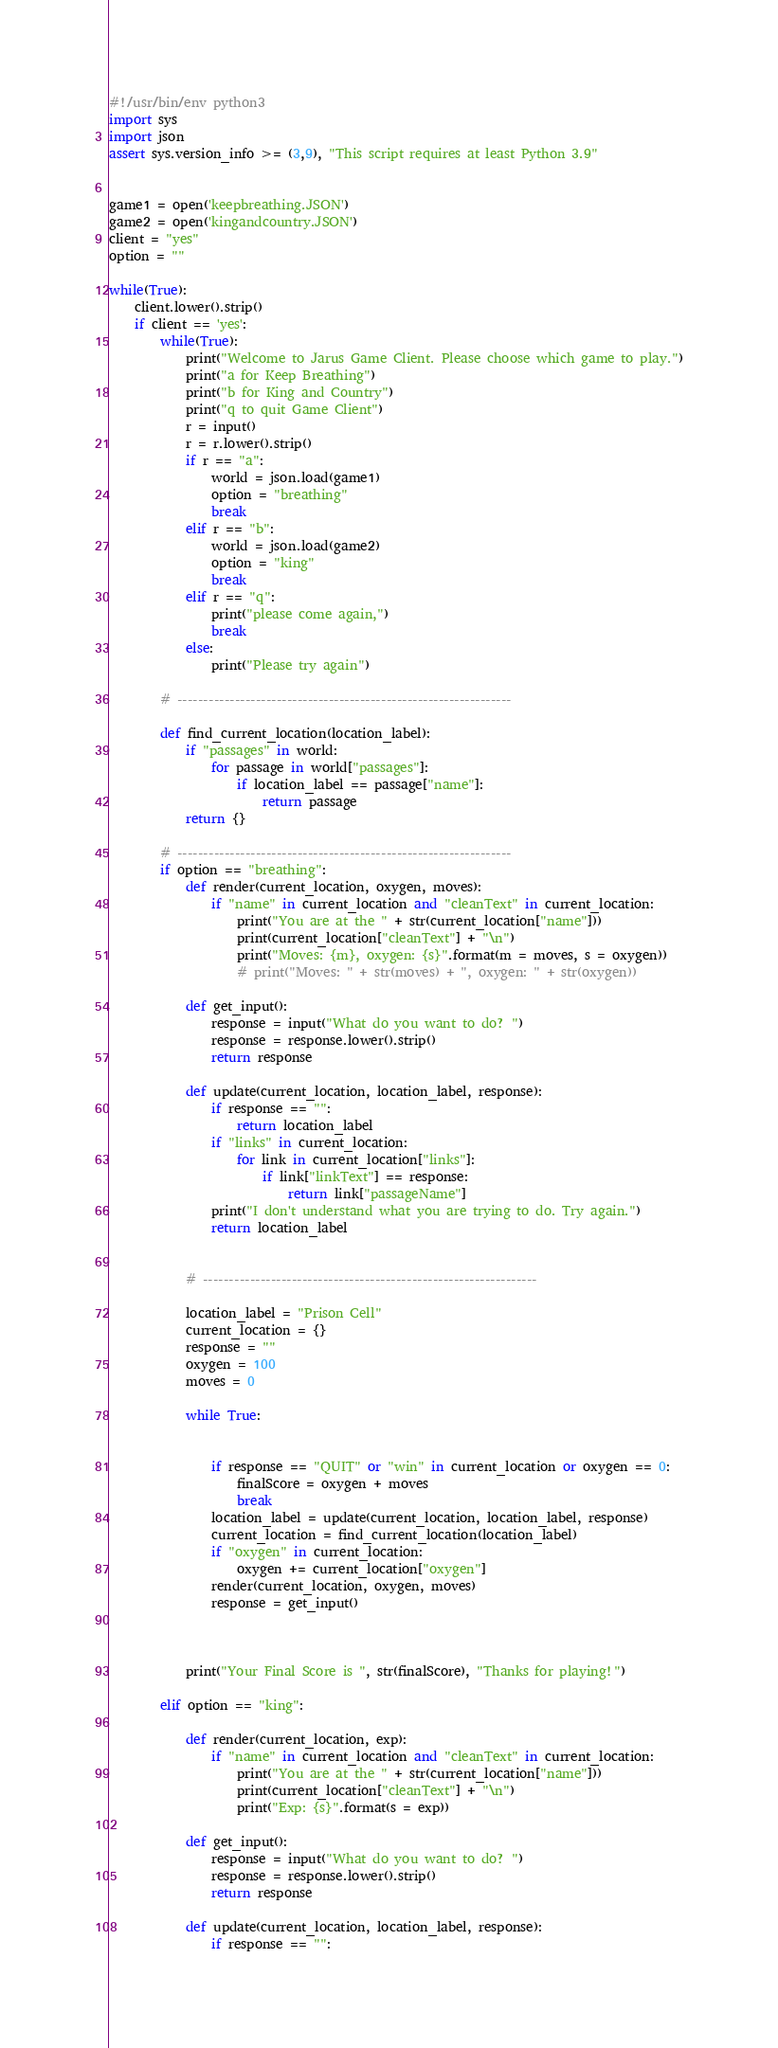<code> <loc_0><loc_0><loc_500><loc_500><_Python_>#!/usr/bin/env python3
import sys
import json
assert sys.version_info >= (3,9), "This script requires at least Python 3.9"


game1 = open('keepbreathing.JSON')
game2 = open('kingandcountry.JSON')
client = "yes"
option = ""

while(True):
	client.lower().strip()
	if client == 'yes':
		while(True):
			print("Welcome to Jarus Game Client. Please choose which game to play.")
			print("a for Keep Breathing")
			print("b for King and Country")
			print("q to quit Game Client")
			r = input()
			r = r.lower().strip()
			if r == "a":
				world = json.load(game1)
				option = "breathing"
				break
			elif r == "b":
				world = json.load(game2)
				option = "king"
				break
			elif r == "q":
				print("please come again,")
				break
			else:
				print("Please try again")

		# ----------------------------------------------------------------

		def find_current_location(location_label):
			if "passages" in world:
				for passage in world["passages"]:
					if location_label == passage["name"]:
						return passage
			return {}

		# ----------------------------------------------------------------
		if option == "breathing":
			def render(current_location, oxygen, moves):
				if "name" in current_location and "cleanText" in current_location:
					print("You are at the " + str(current_location["name"]))
					print(current_location["cleanText"] + "\n")
					print("Moves: {m}, oxygen: {s}".format(m = moves, s = oxygen))
					# print("Moves: " + str(moves) + ", oxygen: " + str(oxygen))

			def get_input():
				response = input("What do you want to do? ")
				response = response.lower().strip()
				return response

			def update(current_location, location_label, response):
				if response == "":
					return location_label
				if "links" in current_location:
					for link in current_location["links"]:
						if link["linkText"] == response:
							return link["passageName"]
				print("I don't understand what you are trying to do. Try again.")
				return location_label


			# ----------------------------------------------------------------

			location_label = "Prison Cell"
			current_location = {}
			response = ""
			oxygen = 100
			moves = 0

			while True:


				if response == "QUIT" or "win" in current_location or oxygen == 0:
					finalScore = oxygen + moves
					break
				location_label = update(current_location, location_label, response)
				current_location = find_current_location(location_label)
				if "oxygen" in current_location:
					oxygen += current_location["oxygen"]
				render(current_location, oxygen, moves)
				response = get_input()
				


			print("Your Final Score is ", str(finalScore), "Thanks for playing!")

		elif option == "king":

			def render(current_location, exp):
				if "name" in current_location and "cleanText" in current_location:
					print("You are at the " + str(current_location["name"]))
					print(current_location["cleanText"] + "\n")
					print("Exp: {s}".format(s = exp))

			def get_input():
				response = input("What do you want to do? ")
				response = response.lower().strip()
				return response

			def update(current_location, location_label, response):
				if response == "":</code> 